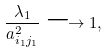<formula> <loc_0><loc_0><loc_500><loc_500>\frac { \lambda _ { 1 } } { a _ { i _ { 1 } j _ { 1 } } ^ { 2 } } \longrightarrow 1 ,</formula> 